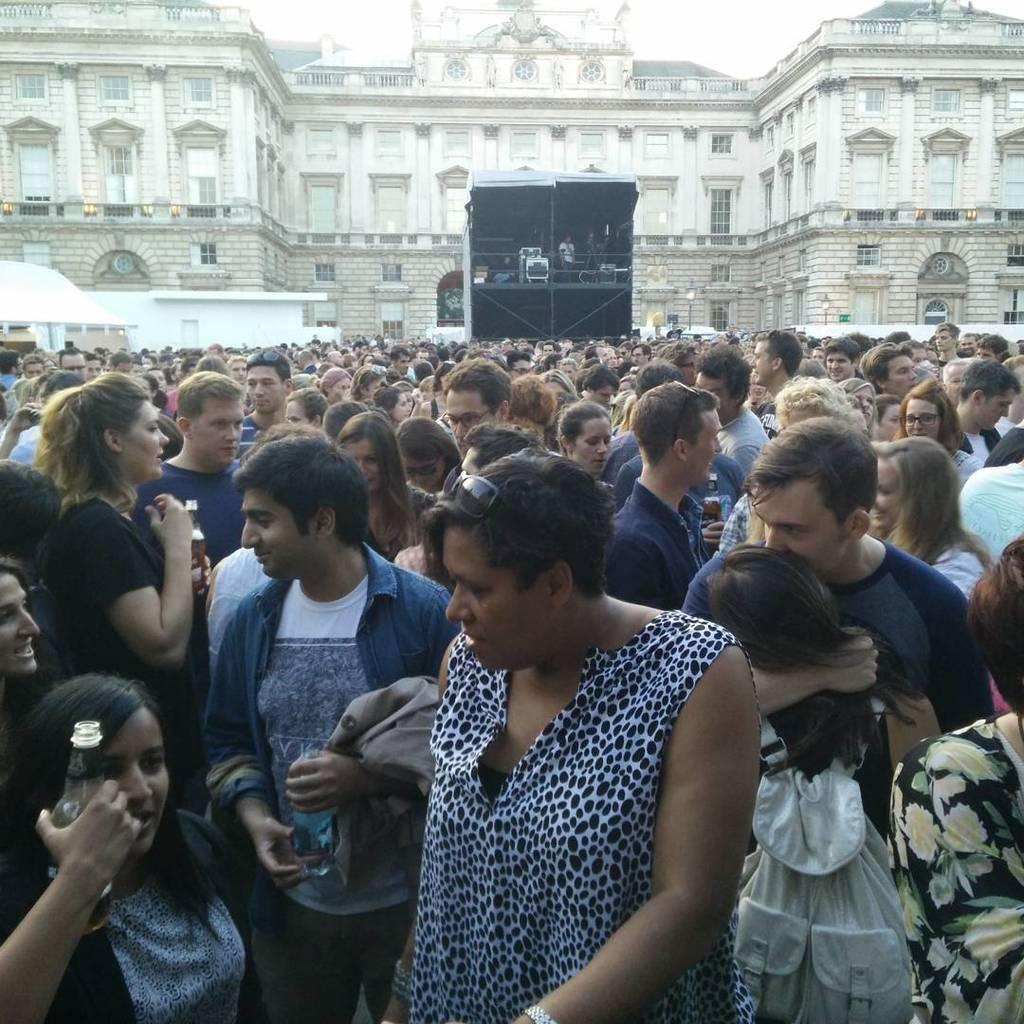What is the main subject of the image? The main subject of the image is a huge crowd. Can you describe the background of the image? There is a massive building behind the crowd in the image. What type of representative can be seen in the image? There is no representative present in the image; it features a huge crowd and a massive building. How does the quartz appear in the image? There is no quartz present in the image. 